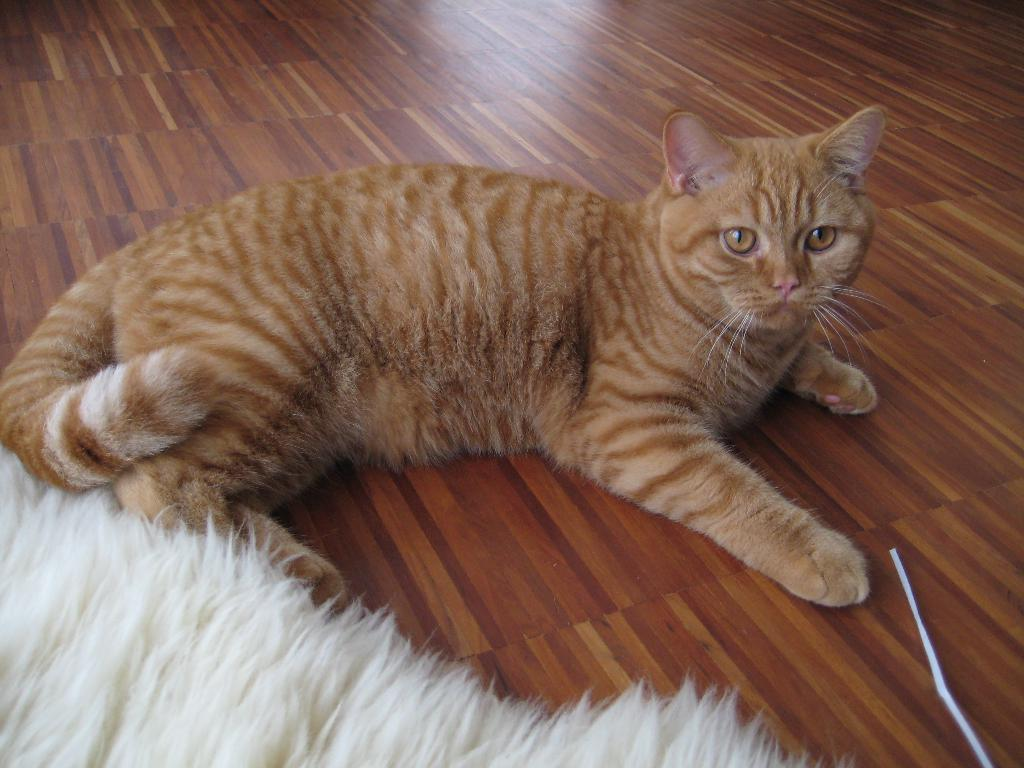What type of animal is in the image? There is a cat in the image. Where is the cat located in the image? The cat is on the floor. What shape is the bird in the image? There is no bird present in the image, so it is not possible to determine its shape. 